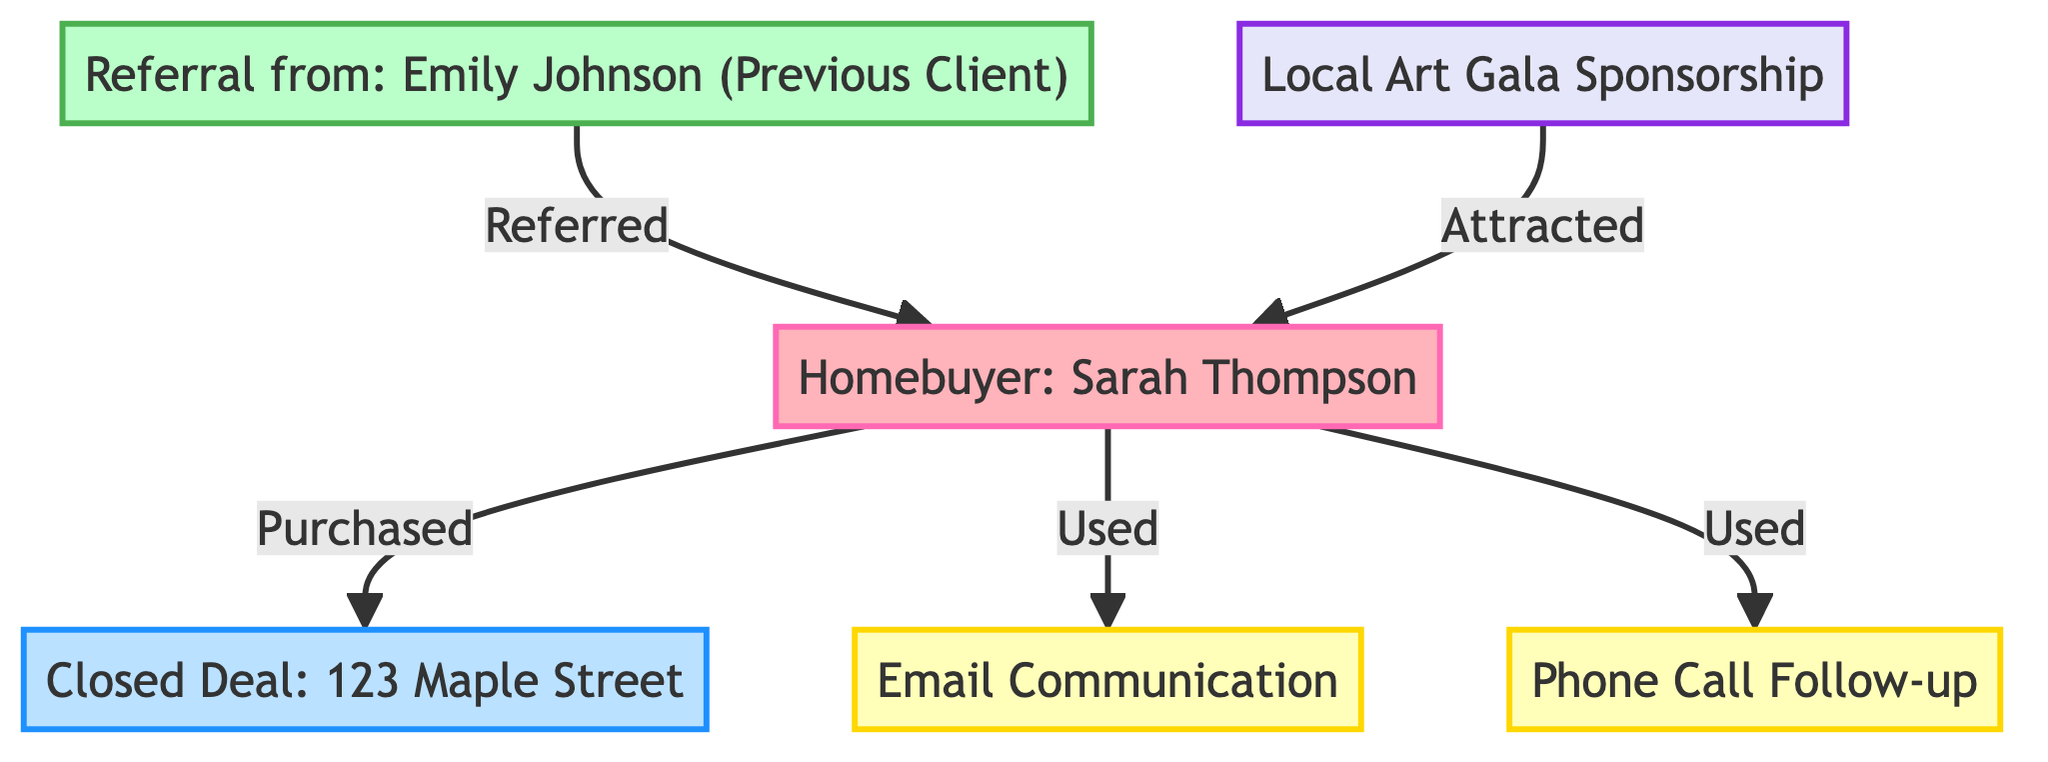What is the name of the homebuyer in the diagram? The diagram explicitly states that the homebuyer is named "Sarah Thompson." This is identified directly under the "Client" node in the diagram.
Answer: Sarah Thompson How many communication channels are shown in the diagram? The diagram highlights two types of communication channels: "Email Communication" and "Phone Call Follow-up." Counting these gives us a total of two communication channels.
Answer: 2 Who referred the homebuyer? The diagram indicates "Emily Johnson (Previous Client)" as the person who made the referral to the homebuyer, as seen in the "Referral" node connecting to the "Client" node.
Answer: Emily Johnson What type of event is mentioned in the diagram? The diagram mentions "Local Art Gala Sponsorship" under the "NetworkingEvent" node, indicating that the event type is an art gala sponsorship.
Answer: Art Gala Sponsorship How did Sarah Thompson become a client? The diagram illustrates that Sarah Thompson became a client through a referral, specifically from "Emily Johnson (Previous Client)," as shown by the arrow leading from the "Referral" node to the "Client" node.
Answer: Referral What transaction is represented in the diagram? The transaction depicted in the diagram is "Closed Deal: 123 Maple Street," which is presented in the "DealClosed" node linking to the "Client" node.
Answer: Closed Deal: 123 Maple Street What are the two methods of communication used by the client? The diagram shows "Email Communication" and "Phone Call Follow-up" as the two methods of communication that Sarah Thompson, the client, utilized, evidenced by the connections from the "Client" node to these two communication nodes.
Answer: Email Communication, Phone Call Follow-up How is the client connected to the networking event? In the diagram, the connection between the client and the networking event is indicated by the relationship "Attracted," showing that the "Local Art Gala Sponsorship" event attracted Sarah Thompson to become a client.
Answer: Attracted Which node relates to a closed deal involving Sarah Thompson? The node directly relating to a closed deal involving Sarah Thompson is "Closed Deal: 123 Maple Street," which is displayed as a transaction node connected to the client node.
Answer: Closed Deal: 123 Maple Street 